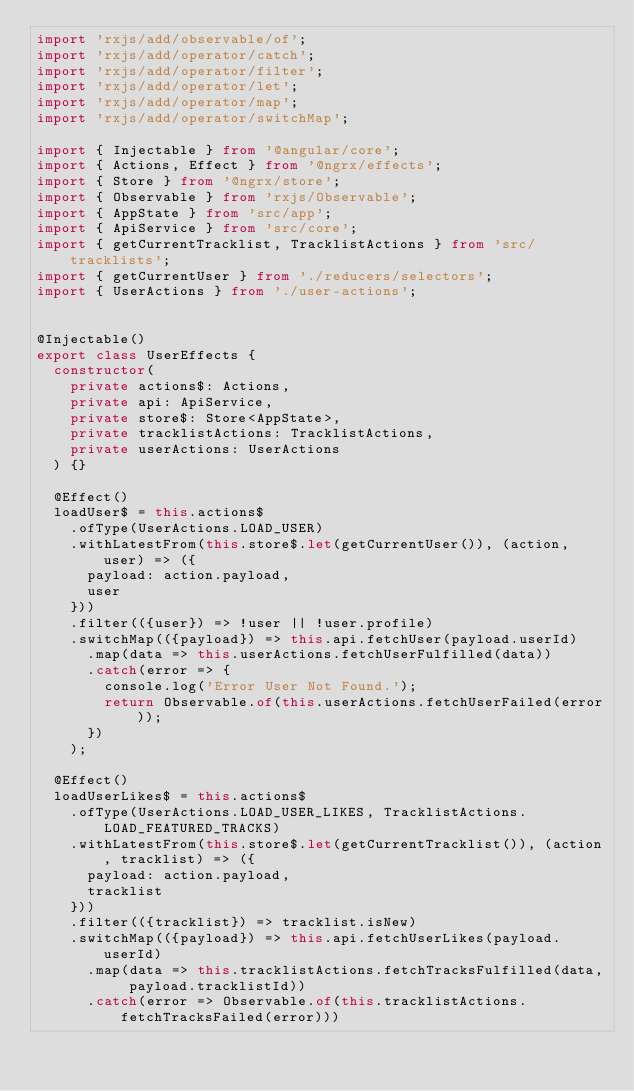<code> <loc_0><loc_0><loc_500><loc_500><_TypeScript_>import 'rxjs/add/observable/of';
import 'rxjs/add/operator/catch';
import 'rxjs/add/operator/filter';
import 'rxjs/add/operator/let';
import 'rxjs/add/operator/map';
import 'rxjs/add/operator/switchMap';

import { Injectable } from '@angular/core';
import { Actions, Effect } from '@ngrx/effects';
import { Store } from '@ngrx/store';
import { Observable } from 'rxjs/Observable';
import { AppState } from 'src/app';
import { ApiService } from 'src/core';
import { getCurrentTracklist, TracklistActions } from 'src/tracklists';
import { getCurrentUser } from './reducers/selectors';
import { UserActions } from './user-actions';


@Injectable()
export class UserEffects {
  constructor(
    private actions$: Actions,
    private api: ApiService,
    private store$: Store<AppState>,
    private tracklistActions: TracklistActions,
    private userActions: UserActions
  ) {}

  @Effect()
  loadUser$ = this.actions$
    .ofType(UserActions.LOAD_USER)
    .withLatestFrom(this.store$.let(getCurrentUser()), (action, user) => ({
      payload: action.payload,
      user
    }))
    .filter(({user}) => !user || !user.profile)
    .switchMap(({payload}) => this.api.fetchUser(payload.userId)
      .map(data => this.userActions.fetchUserFulfilled(data))
      .catch(error => {
        console.log('Error User Not Found.');
        return Observable.of(this.userActions.fetchUserFailed(error));
      })
    );

  @Effect()
  loadUserLikes$ = this.actions$
    .ofType(UserActions.LOAD_USER_LIKES, TracklistActions.LOAD_FEATURED_TRACKS)
    .withLatestFrom(this.store$.let(getCurrentTracklist()), (action, tracklist) => ({
      payload: action.payload,
      tracklist
    }))
    .filter(({tracklist}) => tracklist.isNew)
    .switchMap(({payload}) => this.api.fetchUserLikes(payload.userId)
      .map(data => this.tracklistActions.fetchTracksFulfilled(data, payload.tracklistId))
      .catch(error => Observable.of(this.tracklistActions.fetchTracksFailed(error)))</code> 